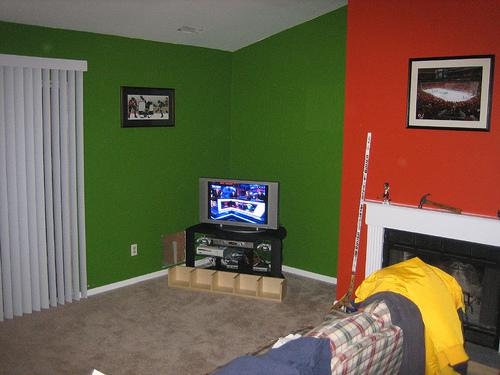Question: why was the picture taken?
Choices:
A. To show the room.
B. To sell.
C. To remember.
D. Advertisement.
Answer with the letter. Answer: A Question: where was the picture taken?
Choices:
A. In the kitchen.
B. In the boat.
C. On the coast.
D. In a living room.
Answer with the letter. Answer: D Question: when was the picture taken?
Choices:
A. At night.
B. When the tv was on.
C. In the morning.
D. At evening.
Answer with the letter. Answer: B 